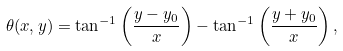Convert formula to latex. <formula><loc_0><loc_0><loc_500><loc_500>\theta ( x , y ) = \tan ^ { - 1 } \left ( \frac { y - y _ { 0 } } { x } \right ) - \tan ^ { - 1 } \left ( \frac { y + y _ { 0 } } { x } \right ) ,</formula> 